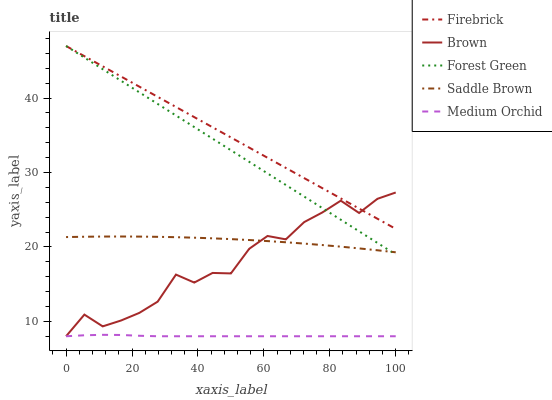Does Medium Orchid have the minimum area under the curve?
Answer yes or no. Yes. Does Firebrick have the maximum area under the curve?
Answer yes or no. Yes. Does Firebrick have the minimum area under the curve?
Answer yes or no. No. Does Medium Orchid have the maximum area under the curve?
Answer yes or no. No. Is Firebrick the smoothest?
Answer yes or no. Yes. Is Brown the roughest?
Answer yes or no. Yes. Is Medium Orchid the smoothest?
Answer yes or no. No. Is Medium Orchid the roughest?
Answer yes or no. No. Does Firebrick have the lowest value?
Answer yes or no. No. Does Forest Green have the highest value?
Answer yes or no. Yes. Does Medium Orchid have the highest value?
Answer yes or no. No. Is Saddle Brown less than Firebrick?
Answer yes or no. Yes. Is Firebrick greater than Medium Orchid?
Answer yes or no. Yes. Does Saddle Brown intersect Firebrick?
Answer yes or no. No. 